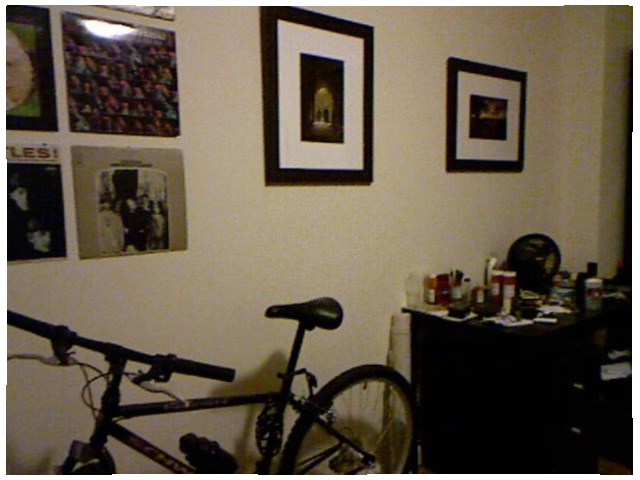<image>
Can you confirm if the fan is under the picture? Yes. The fan is positioned underneath the picture, with the picture above it in the vertical space. Is there a cycle on the wall? No. The cycle is not positioned on the wall. They may be near each other, but the cycle is not supported by or resting on top of the wall. Is there a picture above the bicycle? Yes. The picture is positioned above the bicycle in the vertical space, higher up in the scene. Is the photo in the frame? Yes. The photo is contained within or inside the frame, showing a containment relationship. Is the frame in the frame? No. The frame is not contained within the frame. These objects have a different spatial relationship. 